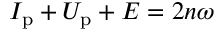Convert formula to latex. <formula><loc_0><loc_0><loc_500><loc_500>I _ { p } + U _ { p } + E = 2 n \omega</formula> 